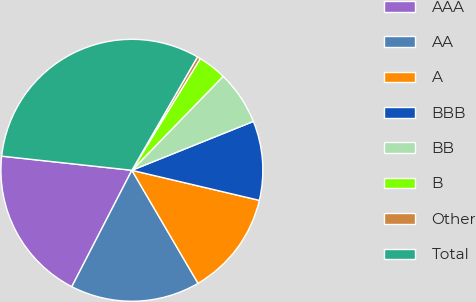Convert chart. <chart><loc_0><loc_0><loc_500><loc_500><pie_chart><fcel>AAA<fcel>AA<fcel>A<fcel>BBB<fcel>BB<fcel>B<fcel>Other<fcel>Total<nl><fcel>19.14%<fcel>16.01%<fcel>12.89%<fcel>9.77%<fcel>6.65%<fcel>3.52%<fcel>0.4%<fcel>31.63%<nl></chart> 